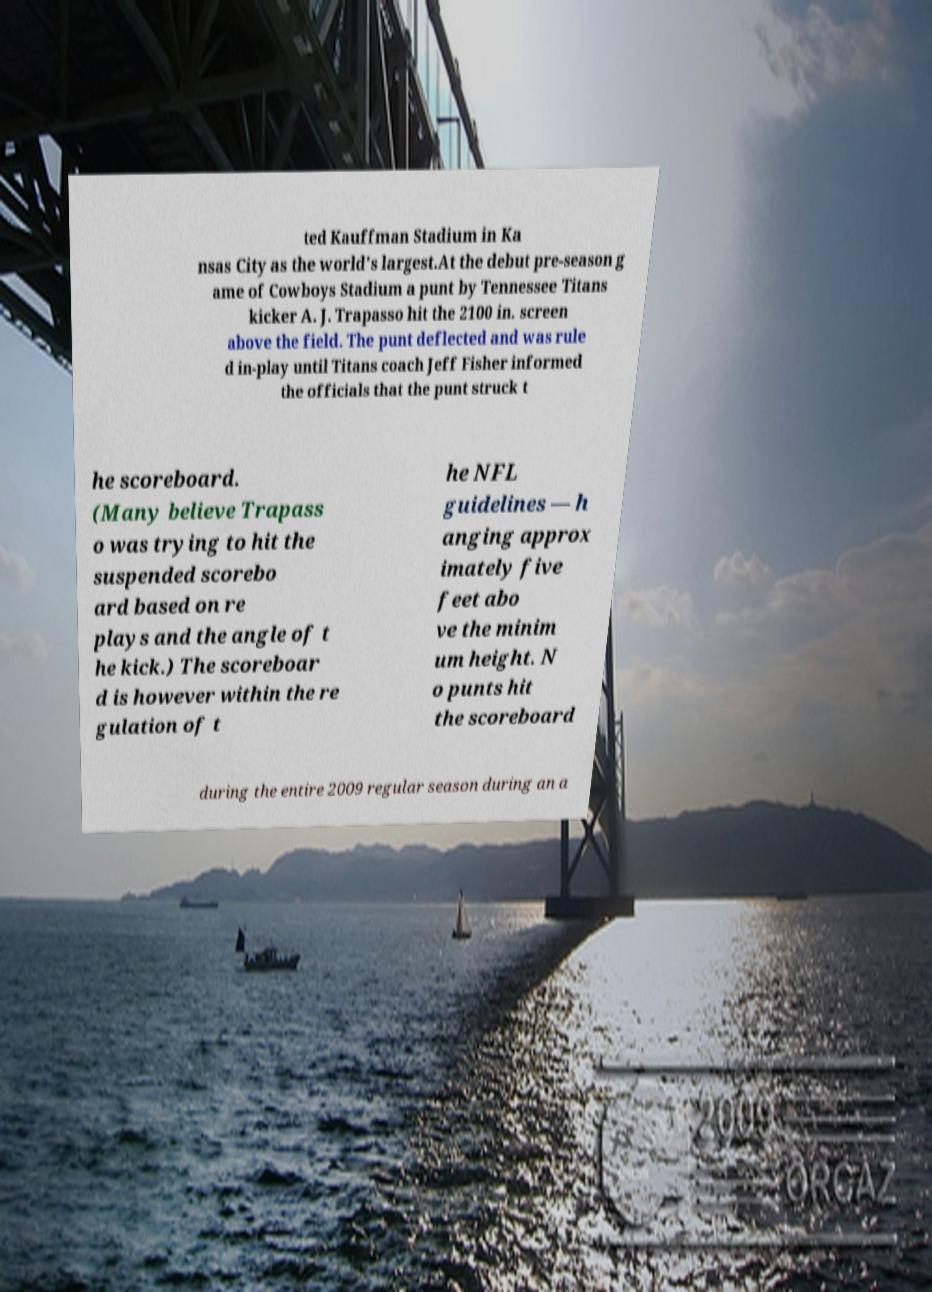There's text embedded in this image that I need extracted. Can you transcribe it verbatim? ted Kauffman Stadium in Ka nsas City as the world's largest.At the debut pre-season g ame of Cowboys Stadium a punt by Tennessee Titans kicker A. J. Trapasso hit the 2100 in. screen above the field. The punt deflected and was rule d in-play until Titans coach Jeff Fisher informed the officials that the punt struck t he scoreboard. (Many believe Trapass o was trying to hit the suspended scorebo ard based on re plays and the angle of t he kick.) The scoreboar d is however within the re gulation of t he NFL guidelines — h anging approx imately five feet abo ve the minim um height. N o punts hit the scoreboard during the entire 2009 regular season during an a 